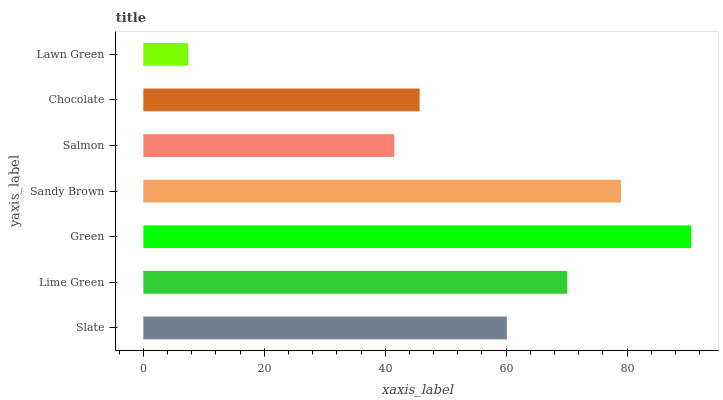Is Lawn Green the minimum?
Answer yes or no. Yes. Is Green the maximum?
Answer yes or no. Yes. Is Lime Green the minimum?
Answer yes or no. No. Is Lime Green the maximum?
Answer yes or no. No. Is Lime Green greater than Slate?
Answer yes or no. Yes. Is Slate less than Lime Green?
Answer yes or no. Yes. Is Slate greater than Lime Green?
Answer yes or no. No. Is Lime Green less than Slate?
Answer yes or no. No. Is Slate the high median?
Answer yes or no. Yes. Is Slate the low median?
Answer yes or no. Yes. Is Lawn Green the high median?
Answer yes or no. No. Is Salmon the low median?
Answer yes or no. No. 